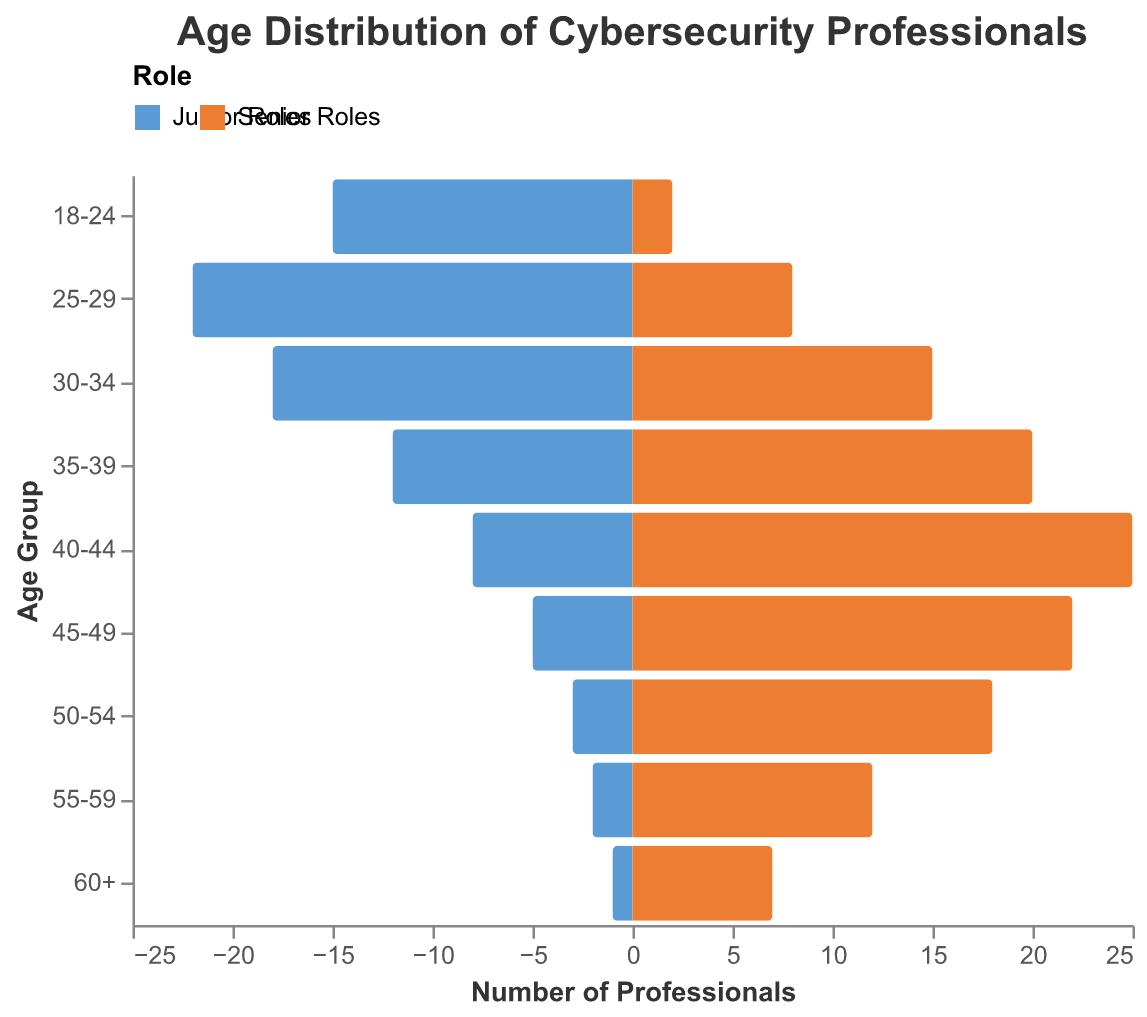What is the age group with the highest number of junior roles? By visually inspecting the bars on the left side of the pyramid representing junior roles, the 25-29 age group has the longest bar. This indicates the highest number of junior roles.
Answer: 25-29 Which role has more professionals in the 30-34 age group, junior or senior? By comparing the length of the bars for the 30-34 age group, the bar for senior roles is longer than the bar for junior roles.
Answer: Senior roles How many more senior roles are there compared to junior roles in the 40-44 age group? The bar for senior roles in the 40-44 age group reaches 25, while the bar for junior roles reaches 8. Calculation: 25 (senior roles) - 8 (junior roles) = 17.
Answer: 17 In which age group(s) do senior roles outnumber junior roles by at least double? By comparing the lengths of bars for each age group, we see that in the 35-39, 40-44, 45-49, and 55-59 age groups, the senior roles are at least twice as many as junior roles. For example, in the 40-44 age group, there are 25 senior roles and 8 junior roles, which satisfies the condition of at least double.
Answer: 35-39, 40-44, 45-49, 55-59 What is the total number of junior roles across all age groups? To find the total number of junior roles, sum up the junior role counts for each age group: 15 + 22 + 18 + 12 + 8 + 5 + 3 + 2 + 1 = 86.
Answer: 86 What percentage of junior roles does the 25-29 age group represent? First, calculate the total number of junior roles (86). Then find the number of junior roles in the 25-29 age group (22). Finally, use the formula (22 / 86) * 100 to get the percentage: 25.58%.
Answer: 25.58% How does the gap between junior and senior roles change as age increases? Observing the figure from bottom to top, the gap starts with juniors outnumbering seniors in younger age groups. Around 30-34, the numbers start to balance out, and from 35-39 onwards, senior roles progressively become more dominant compared to junior roles as age increases.
Answer: Increased dominance of senior roles Which age group has the smallest total number of roles? Sum both junior and senior roles for each age group and identify the smallest total. For the 60+ age group: 1 (junior) + 7 (senior) = 8 roles. This is the smallest among all.
Answer: 60+ What is the total number of professionals in the 35-39 age group? Add the number of junior and senior roles within the 35-39 age group: 12 (junior) + 20 (senior) = 32 professionals.
Answer: 32 